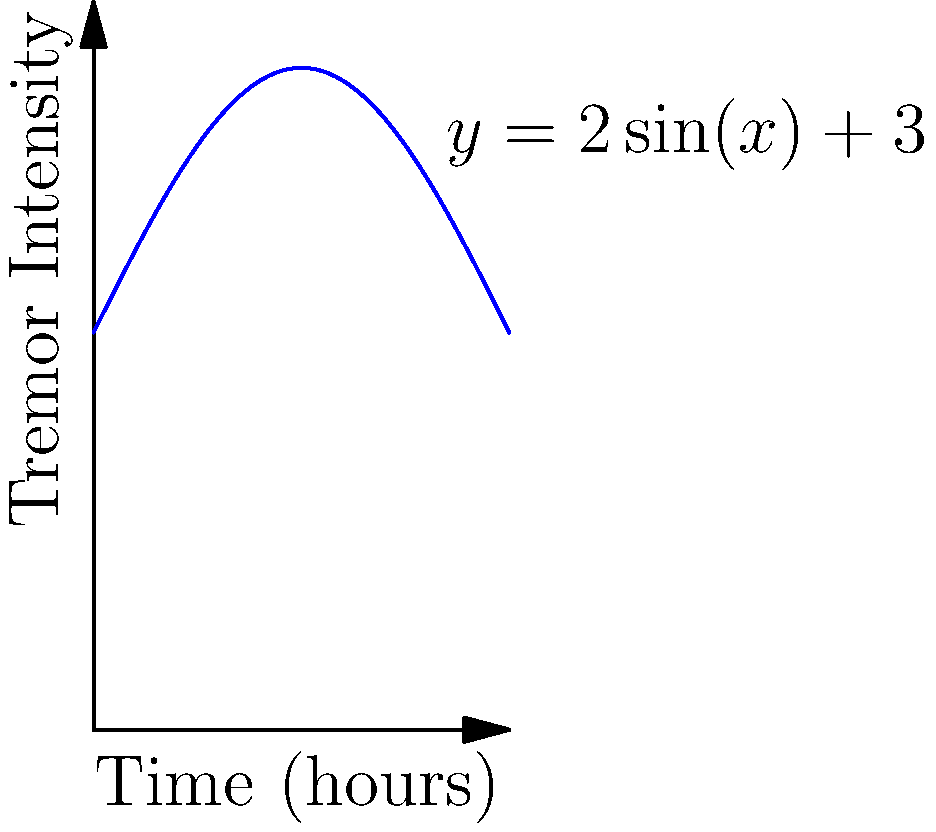The graph represents the tremor intensity of a Parkinson's patient over a 12-hour period, modeled by the function $y = 2\sin(x) + 3$, where $x$ is time in hours (ranging from 0 to $\pi$) and $y$ is tremor intensity. Calculate the average tremor intensity over this period. To find the average tremor intensity, we need to:

1) Calculate the area under the curve (total tremor intensity)
2) Divide this area by the time period (12 hours)

Step 1: Calculate the area under the curve

The area is given by the definite integral:

$$A = \int_0^\pi (2\sin(x) + 3) dx$$

Let's solve this integral:

$$A = [-2\cos(x) + 3x]_0^\pi$$
$$A = [-2\cos(\pi) + 3\pi] - [-2\cos(0) + 3(0)]$$
$$A = [2 + 3\pi] - [-2]$$
$$A = 2 + 3\pi + 2 = 3\pi + 4$$

Step 2: Divide by the time period

The time period is $\pi$ hours (equivalent to 12 hours in this model).

Average tremor intensity = $\frac{3\pi + 4}{\pi} = 3 + \frac{4}{\pi}$

Therefore, the average tremor intensity over the 12-hour period is $3 + \frac{4}{\pi}$.
Answer: $3 + \frac{4}{\pi}$ 